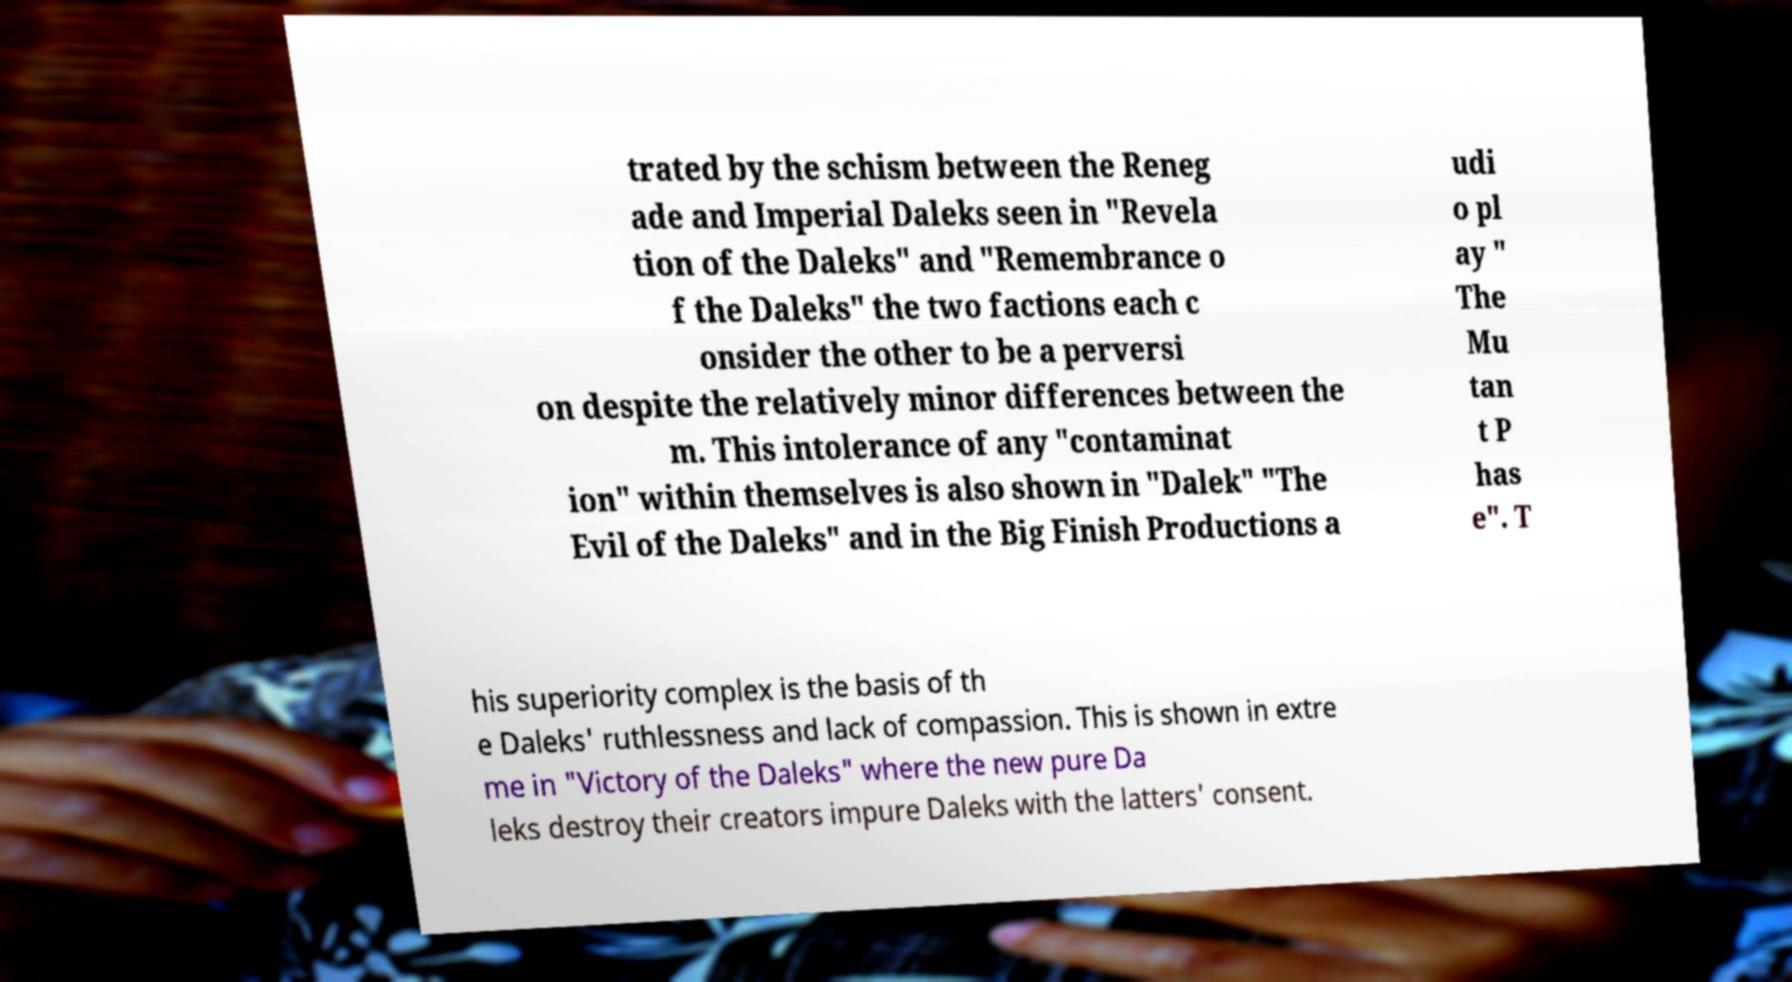Could you extract and type out the text from this image? trated by the schism between the Reneg ade and Imperial Daleks seen in "Revela tion of the Daleks" and "Remembrance o f the Daleks" the two factions each c onsider the other to be a perversi on despite the relatively minor differences between the m. This intolerance of any "contaminat ion" within themselves is also shown in "Dalek" "The Evil of the Daleks" and in the Big Finish Productions a udi o pl ay " The Mu tan t P has e". T his superiority complex is the basis of th e Daleks' ruthlessness and lack of compassion. This is shown in extre me in "Victory of the Daleks" where the new pure Da leks destroy their creators impure Daleks with the latters' consent. 